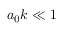<formula> <loc_0><loc_0><loc_500><loc_500>a _ { 0 } k \ll 1</formula> 